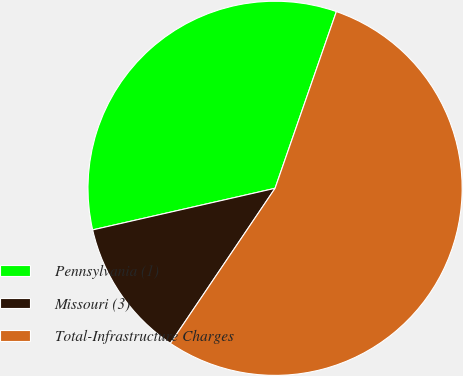Convert chart to OTSL. <chart><loc_0><loc_0><loc_500><loc_500><pie_chart><fcel>Pennsylvania (1)<fcel>Missouri (3)<fcel>Total-Infrastructure Charges<nl><fcel>33.88%<fcel>11.98%<fcel>54.13%<nl></chart> 